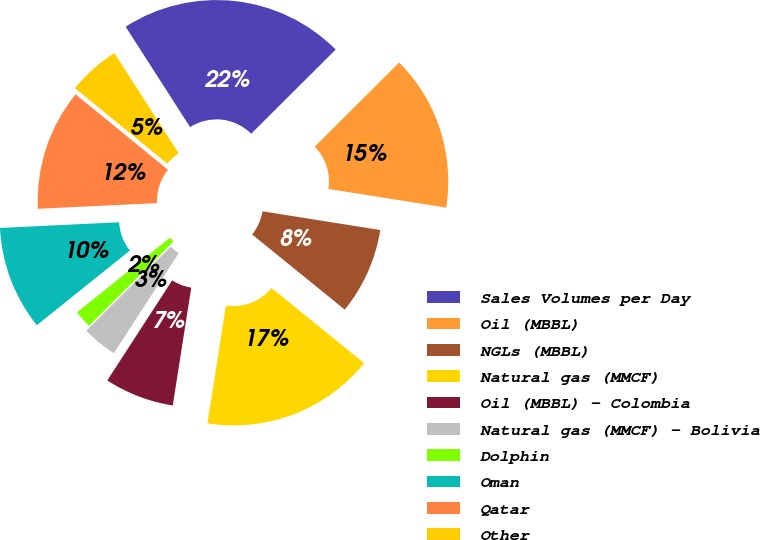<chart> <loc_0><loc_0><loc_500><loc_500><pie_chart><fcel>Sales Volumes per Day<fcel>Oil (MBBL)<fcel>NGLs (MBBL)<fcel>Natural gas (MMCF)<fcel>Oil (MBBL) - Colombia<fcel>Natural gas (MMCF) - Bolivia<fcel>Dolphin<fcel>Oman<fcel>Qatar<fcel>Other<nl><fcel>21.61%<fcel>14.98%<fcel>8.34%<fcel>16.63%<fcel>6.68%<fcel>3.37%<fcel>1.71%<fcel>10.0%<fcel>11.66%<fcel>5.02%<nl></chart> 